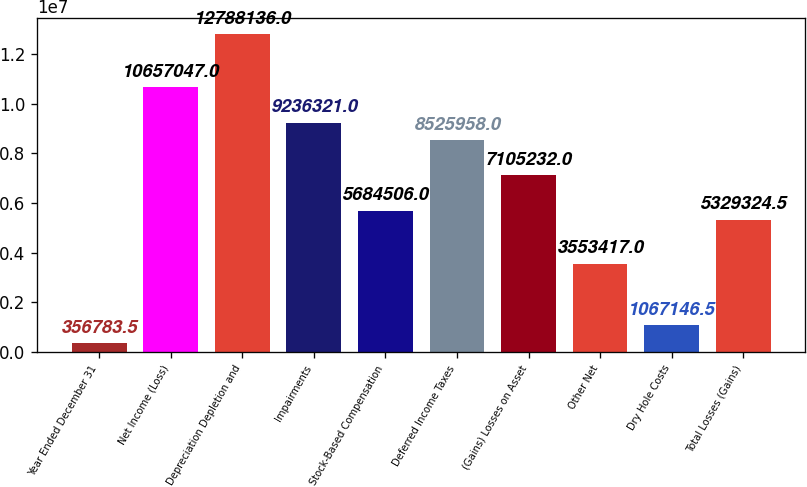Convert chart to OTSL. <chart><loc_0><loc_0><loc_500><loc_500><bar_chart><fcel>Year Ended December 31<fcel>Net Income (Loss)<fcel>Depreciation Depletion and<fcel>Impairments<fcel>Stock-Based Compensation<fcel>Deferred Income Taxes<fcel>(Gains) Losses on Asset<fcel>Other Net<fcel>Dry Hole Costs<fcel>Total Losses (Gains)<nl><fcel>356784<fcel>1.0657e+07<fcel>1.27881e+07<fcel>9.23632e+06<fcel>5.68451e+06<fcel>8.52596e+06<fcel>7.10523e+06<fcel>3.55342e+06<fcel>1.06715e+06<fcel>5.32932e+06<nl></chart> 